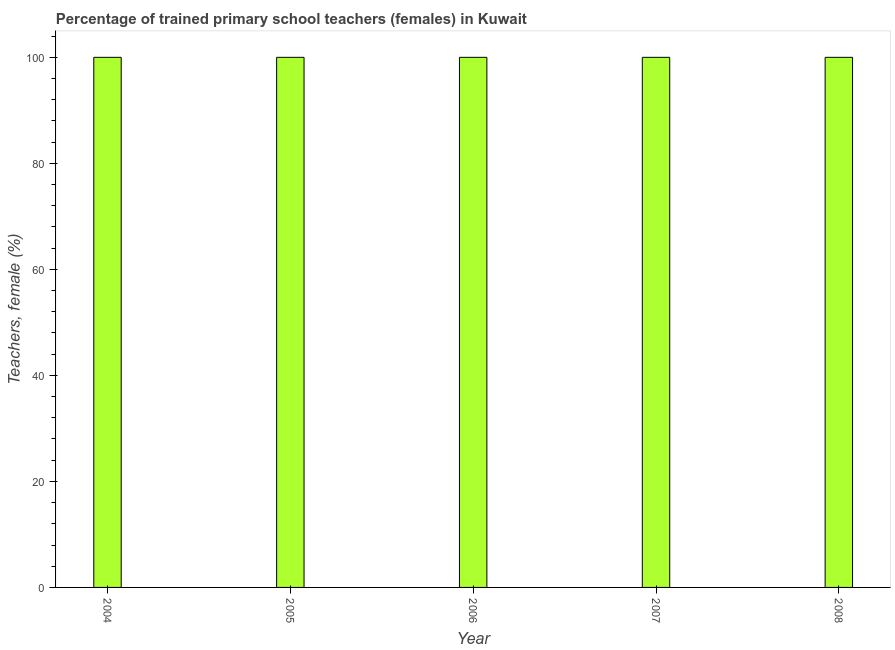What is the title of the graph?
Make the answer very short. Percentage of trained primary school teachers (females) in Kuwait. What is the label or title of the X-axis?
Your answer should be very brief. Year. What is the label or title of the Y-axis?
Provide a succinct answer. Teachers, female (%). Across all years, what is the maximum percentage of trained female teachers?
Your answer should be very brief. 100. Across all years, what is the minimum percentage of trained female teachers?
Offer a terse response. 100. In which year was the percentage of trained female teachers maximum?
Provide a short and direct response. 2004. In how many years, is the percentage of trained female teachers greater than 56 %?
Make the answer very short. 5. What is the ratio of the percentage of trained female teachers in 2004 to that in 2005?
Your answer should be very brief. 1. Is the percentage of trained female teachers in 2007 less than that in 2008?
Your response must be concise. No. Is the difference between the percentage of trained female teachers in 2004 and 2007 greater than the difference between any two years?
Keep it short and to the point. Yes. What is the difference between the highest and the second highest percentage of trained female teachers?
Provide a succinct answer. 0. In how many years, is the percentage of trained female teachers greater than the average percentage of trained female teachers taken over all years?
Your answer should be very brief. 0. How many bars are there?
Offer a terse response. 5. What is the difference between two consecutive major ticks on the Y-axis?
Offer a very short reply. 20. What is the Teachers, female (%) of 2007?
Your answer should be compact. 100. What is the difference between the Teachers, female (%) in 2004 and 2005?
Give a very brief answer. 0. What is the difference between the Teachers, female (%) in 2004 and 2006?
Your response must be concise. 0. What is the difference between the Teachers, female (%) in 2005 and 2006?
Give a very brief answer. 0. What is the difference between the Teachers, female (%) in 2005 and 2007?
Provide a short and direct response. 0. What is the difference between the Teachers, female (%) in 2005 and 2008?
Ensure brevity in your answer.  0. What is the difference between the Teachers, female (%) in 2006 and 2007?
Your answer should be compact. 0. What is the difference between the Teachers, female (%) in 2006 and 2008?
Your response must be concise. 0. What is the difference between the Teachers, female (%) in 2007 and 2008?
Offer a terse response. 0. What is the ratio of the Teachers, female (%) in 2004 to that in 2007?
Your answer should be compact. 1. What is the ratio of the Teachers, female (%) in 2005 to that in 2006?
Provide a succinct answer. 1. What is the ratio of the Teachers, female (%) in 2005 to that in 2008?
Provide a succinct answer. 1. What is the ratio of the Teachers, female (%) in 2006 to that in 2007?
Provide a short and direct response. 1. What is the ratio of the Teachers, female (%) in 2006 to that in 2008?
Offer a very short reply. 1. 